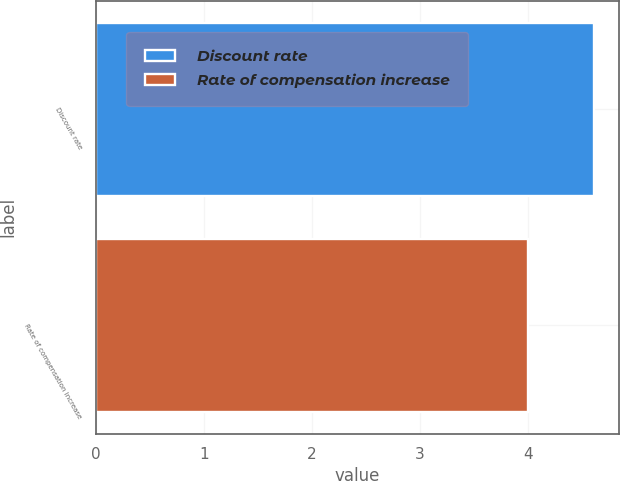Convert chart. <chart><loc_0><loc_0><loc_500><loc_500><bar_chart><fcel>Discount rate<fcel>Rate of compensation increase<nl><fcel>4.61<fcel>4<nl></chart> 